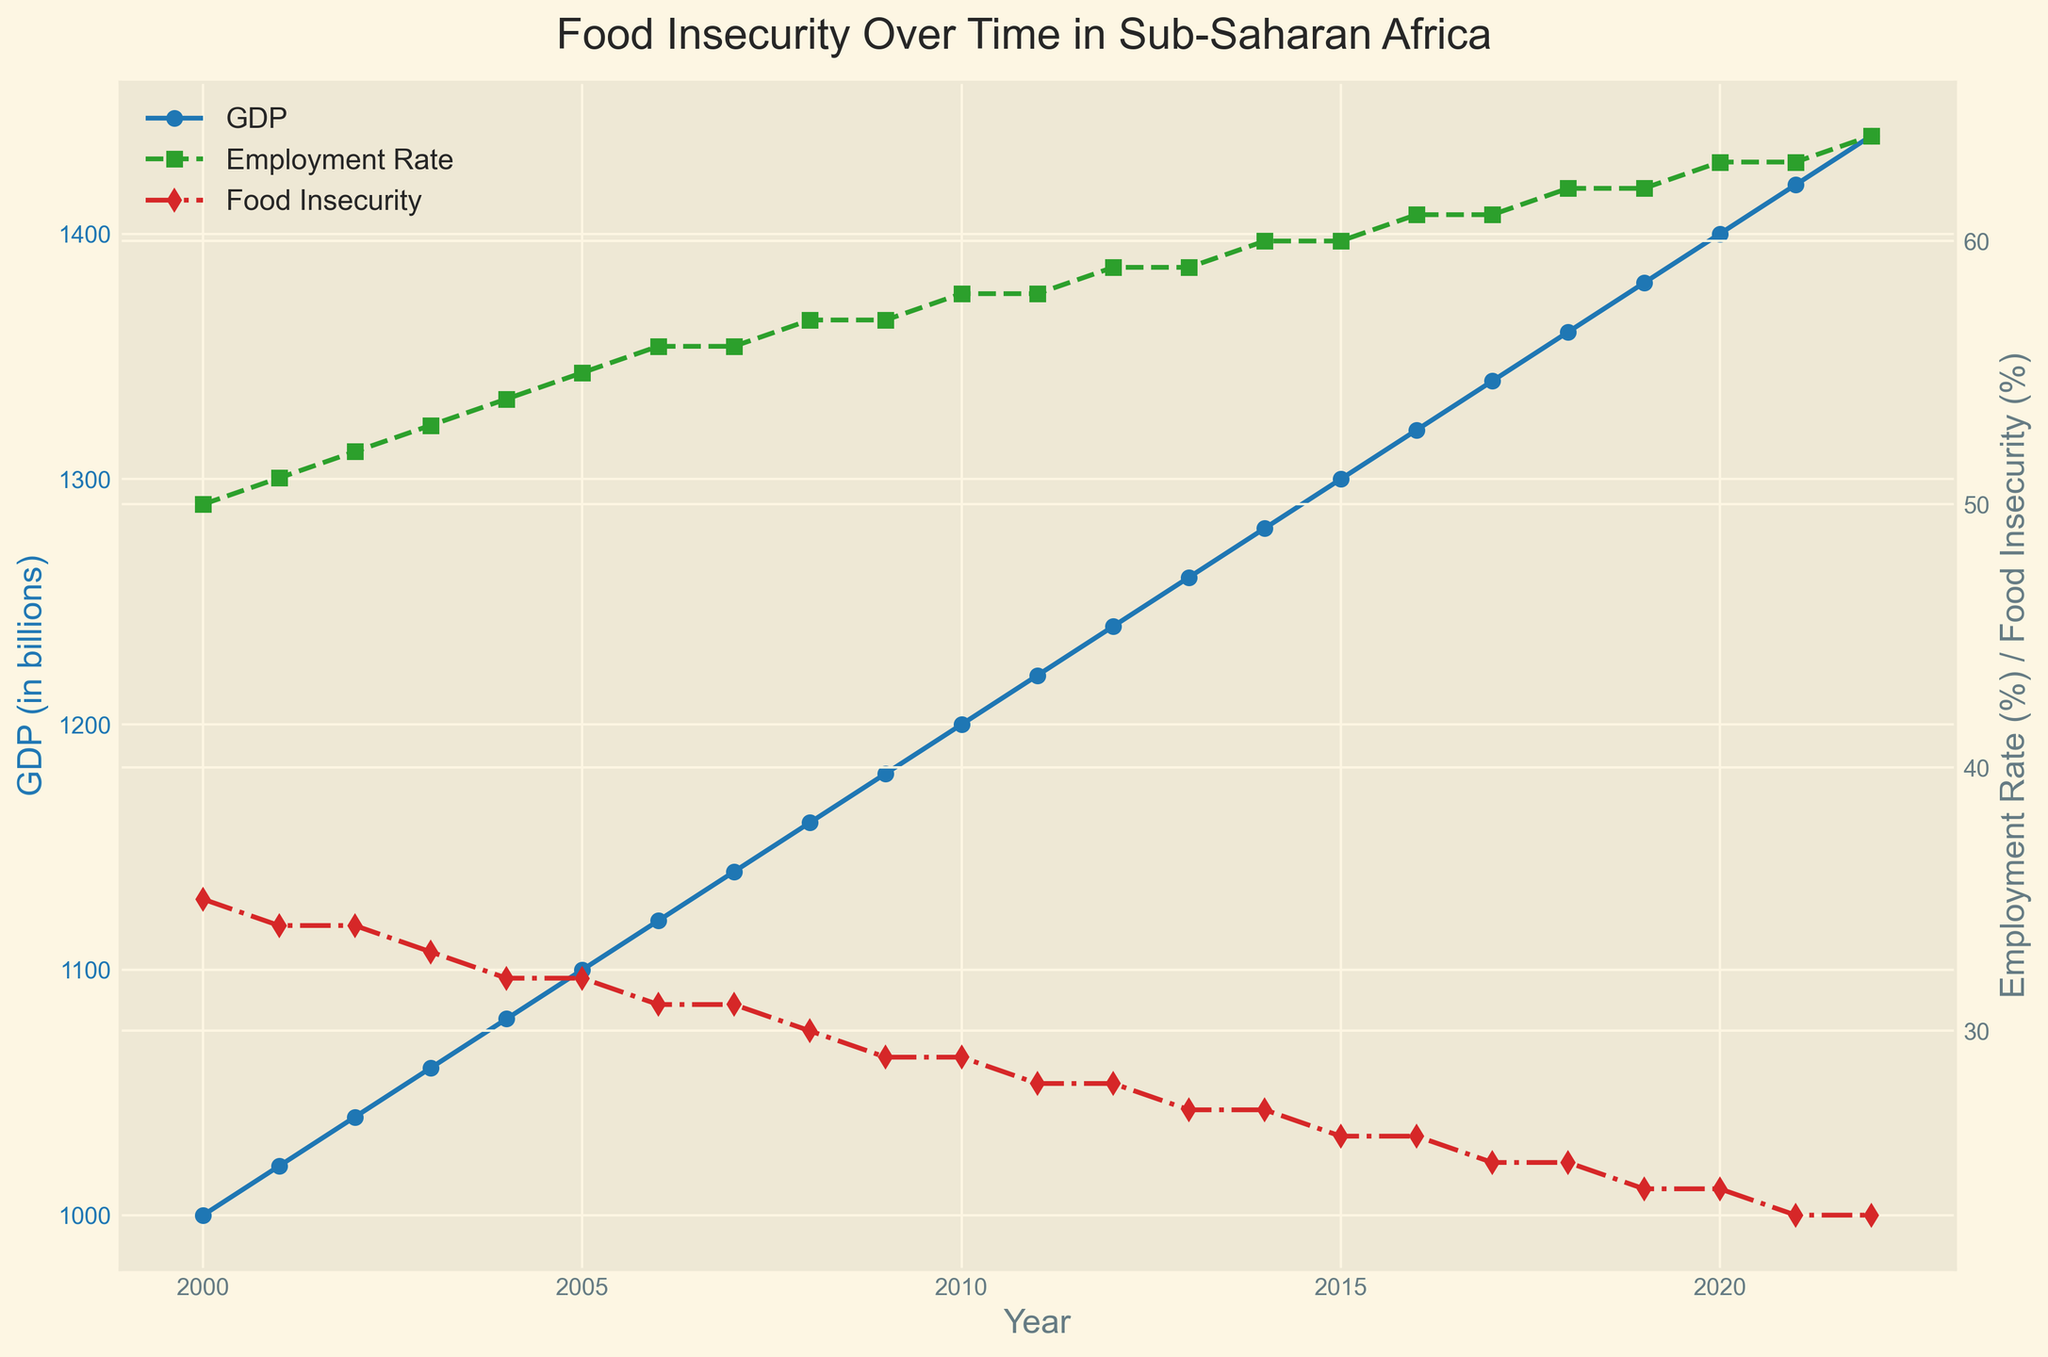What trends can you see in GDP and Food Insecurity over the years? GDP steadily increases over the years while Food Insecurity steadily decreases. Look at the blue line (GDP) which consistently moves upward from 2000 to 2022. On the other hand, the red line (Food Insecurity) moves downward over the same period, indicating a decrease in food insecurity.
Answer: GDP increases, Food Insecurity decreases In which year does Food Insecurity drop below 30%? Follow the red line representing Food Insecurity and identify the first year it is below 30%, which is around 2009.
Answer: 2009 How does the Employment Rate in 2010 compare to the Employment Rate in 2020? Locate the green dashed line that represents Employment Rate. In 2010, it is at approximately 58%. In 2020, it is about 63%. Compare these two values.
Answer: 2020 has a higher Employment Rate How much has GDP increased from 2000 to 2022? Locate the blue line representing GDP. In 2000, the GDP is 1000, and in 2022, it is 1440. The increase can be calculated by subtracting the earlier value from the later one: 1440 - 1000 = 440 billion.
Answer: 440 billion By how much did Food Insecurity decrease from 2000 to 2022? Find the red line for Food Insecurity. In 2000, it was 35%, and in 2022, it is 23%. Subtract the latter from the former: 35% - 23% = 12%.
Answer: 12% Which has the larger overall decline, Food Insecurity between 2000 and 2022, or the rise in Employment Rate within the same period? Food Insecurity decreases by 12% (from 35% to 23%). Employment Rate increases from 50% to 64%, by 14%. Compare these two percentages.
Answer: Employment Rate rise How does the trend in GDP correlate with Food Insecurity between 2000 and 2022? Observe that as GDP increases (blue line moves upward), Food Insecurity decreases (red line moves downward). This suggests a negative correlation between GDP and Food Insecurity.
Answer: Negative correlation In which year do Employment Rate and Food Insecurity intersect? Look for the intersection point between the green dashed line (Employment Rate) and the red dashed line (Food Insecurity). They intersect around the year 2008.
Answer: 2008 What visual indicators show the overall improvement in socioeconomic conditions between 2000 and 2022? Note that the blue line (GDP) shows continuous growth, the green dashed line (Employment Rate) shows an upward trend, and the red dashed line (Food Insecurity) shows a downward trend. These combined indicate an overall improvement.
Answer: GDP up, Employment Rate up, Food Insecurity down 